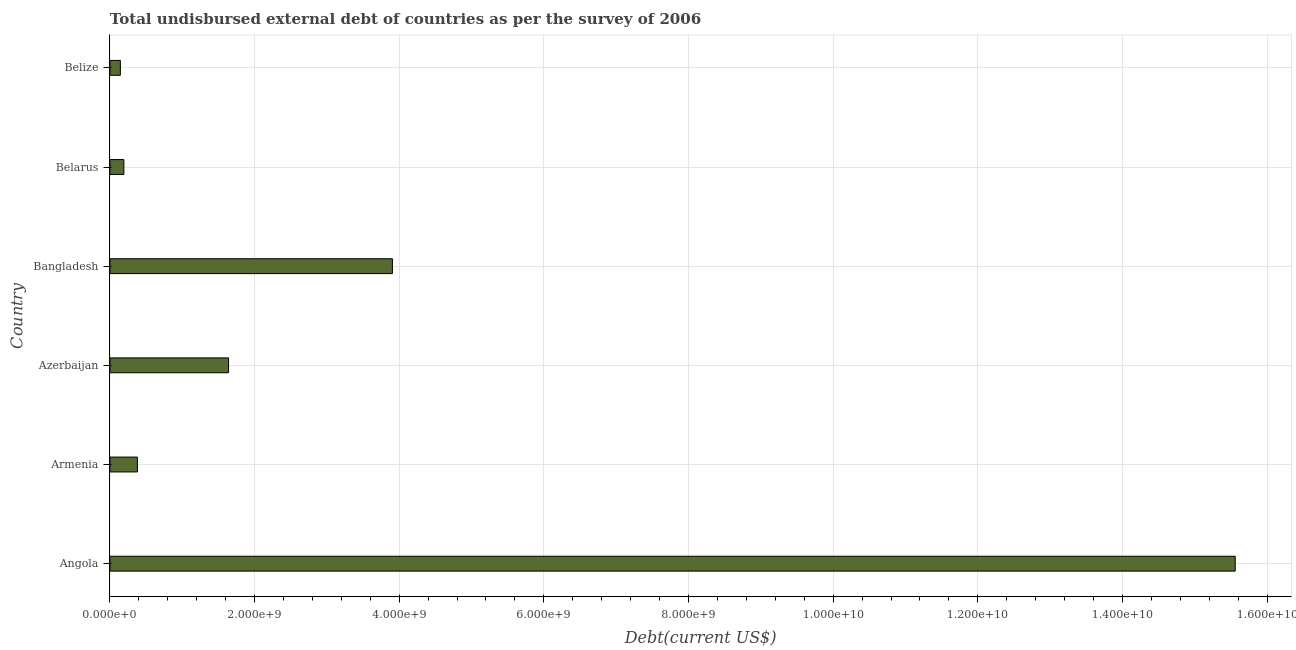What is the title of the graph?
Your response must be concise. Total undisbursed external debt of countries as per the survey of 2006. What is the label or title of the X-axis?
Your answer should be very brief. Debt(current US$). What is the label or title of the Y-axis?
Keep it short and to the point. Country. What is the total debt in Azerbaijan?
Make the answer very short. 1.64e+09. Across all countries, what is the maximum total debt?
Your answer should be very brief. 1.56e+1. Across all countries, what is the minimum total debt?
Make the answer very short. 1.45e+08. In which country was the total debt maximum?
Give a very brief answer. Angola. In which country was the total debt minimum?
Provide a succinct answer. Belize. What is the sum of the total debt?
Ensure brevity in your answer.  2.18e+1. What is the difference between the total debt in Armenia and Bangladesh?
Your answer should be compact. -3.53e+09. What is the average total debt per country?
Keep it short and to the point. 3.64e+09. What is the median total debt?
Keep it short and to the point. 1.01e+09. What is the ratio of the total debt in Armenia to that in Belarus?
Offer a very short reply. 1.97. Is the total debt in Angola less than that in Armenia?
Provide a succinct answer. No. What is the difference between the highest and the second highest total debt?
Give a very brief answer. 1.17e+1. Is the sum of the total debt in Armenia and Bangladesh greater than the maximum total debt across all countries?
Your answer should be compact. No. What is the difference between the highest and the lowest total debt?
Offer a very short reply. 1.54e+1. In how many countries, is the total debt greater than the average total debt taken over all countries?
Make the answer very short. 2. How many countries are there in the graph?
Give a very brief answer. 6. What is the difference between two consecutive major ticks on the X-axis?
Make the answer very short. 2.00e+09. What is the Debt(current US$) of Angola?
Your response must be concise. 1.56e+1. What is the Debt(current US$) of Armenia?
Give a very brief answer. 3.81e+08. What is the Debt(current US$) of Azerbaijan?
Offer a terse response. 1.64e+09. What is the Debt(current US$) in Bangladesh?
Offer a very short reply. 3.91e+09. What is the Debt(current US$) in Belarus?
Give a very brief answer. 1.93e+08. What is the Debt(current US$) in Belize?
Your answer should be compact. 1.45e+08. What is the difference between the Debt(current US$) in Angola and Armenia?
Your response must be concise. 1.52e+1. What is the difference between the Debt(current US$) in Angola and Azerbaijan?
Ensure brevity in your answer.  1.39e+1. What is the difference between the Debt(current US$) in Angola and Bangladesh?
Keep it short and to the point. 1.17e+1. What is the difference between the Debt(current US$) in Angola and Belarus?
Offer a terse response. 1.54e+1. What is the difference between the Debt(current US$) in Angola and Belize?
Make the answer very short. 1.54e+1. What is the difference between the Debt(current US$) in Armenia and Azerbaijan?
Provide a succinct answer. -1.26e+09. What is the difference between the Debt(current US$) in Armenia and Bangladesh?
Give a very brief answer. -3.53e+09. What is the difference between the Debt(current US$) in Armenia and Belarus?
Give a very brief answer. 1.87e+08. What is the difference between the Debt(current US$) in Armenia and Belize?
Your answer should be compact. 2.36e+08. What is the difference between the Debt(current US$) in Azerbaijan and Bangladesh?
Keep it short and to the point. -2.27e+09. What is the difference between the Debt(current US$) in Azerbaijan and Belarus?
Provide a succinct answer. 1.45e+09. What is the difference between the Debt(current US$) in Azerbaijan and Belize?
Ensure brevity in your answer.  1.50e+09. What is the difference between the Debt(current US$) in Bangladesh and Belarus?
Offer a very short reply. 3.71e+09. What is the difference between the Debt(current US$) in Bangladesh and Belize?
Make the answer very short. 3.76e+09. What is the difference between the Debt(current US$) in Belarus and Belize?
Give a very brief answer. 4.83e+07. What is the ratio of the Debt(current US$) in Angola to that in Armenia?
Ensure brevity in your answer.  40.87. What is the ratio of the Debt(current US$) in Angola to that in Azerbaijan?
Ensure brevity in your answer.  9.48. What is the ratio of the Debt(current US$) in Angola to that in Bangladesh?
Your answer should be compact. 3.98. What is the ratio of the Debt(current US$) in Angola to that in Belarus?
Provide a succinct answer. 80.53. What is the ratio of the Debt(current US$) in Angola to that in Belize?
Your response must be concise. 107.39. What is the ratio of the Debt(current US$) in Armenia to that in Azerbaijan?
Make the answer very short. 0.23. What is the ratio of the Debt(current US$) in Armenia to that in Bangladesh?
Keep it short and to the point. 0.1. What is the ratio of the Debt(current US$) in Armenia to that in Belarus?
Give a very brief answer. 1.97. What is the ratio of the Debt(current US$) in Armenia to that in Belize?
Keep it short and to the point. 2.63. What is the ratio of the Debt(current US$) in Azerbaijan to that in Bangladesh?
Make the answer very short. 0.42. What is the ratio of the Debt(current US$) in Azerbaijan to that in Belarus?
Give a very brief answer. 8.49. What is the ratio of the Debt(current US$) in Azerbaijan to that in Belize?
Your answer should be compact. 11.32. What is the ratio of the Debt(current US$) in Bangladesh to that in Belarus?
Provide a succinct answer. 20.22. What is the ratio of the Debt(current US$) in Bangladesh to that in Belize?
Your answer should be very brief. 26.96. What is the ratio of the Debt(current US$) in Belarus to that in Belize?
Keep it short and to the point. 1.33. 